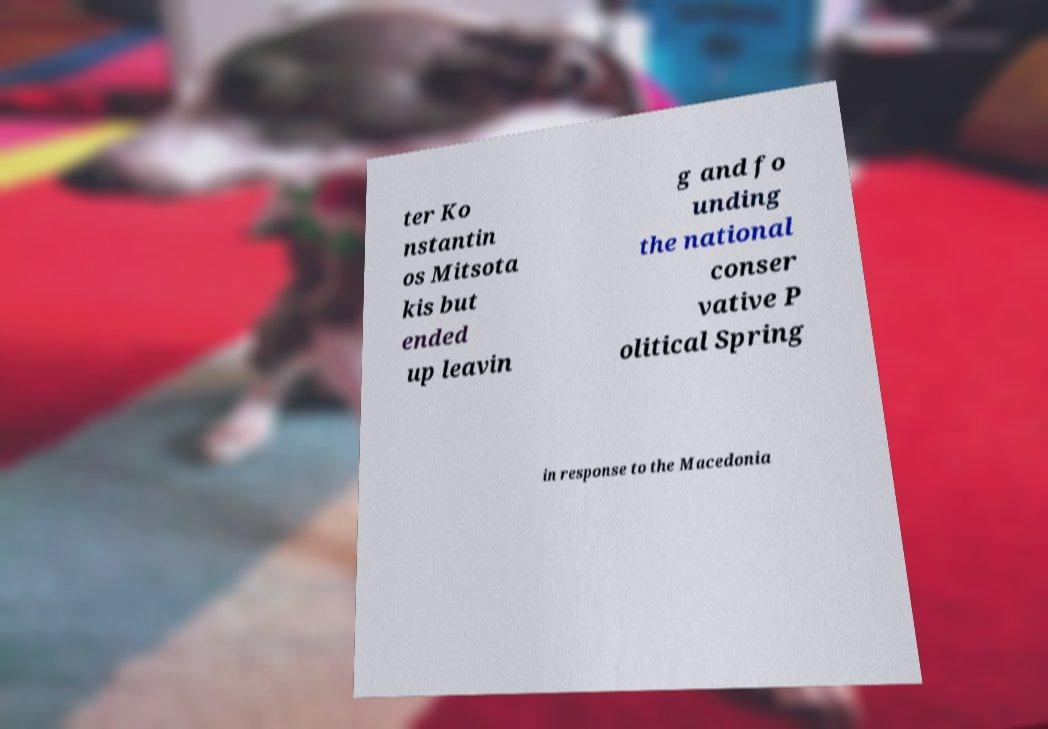There's text embedded in this image that I need extracted. Can you transcribe it verbatim? ter Ko nstantin os Mitsota kis but ended up leavin g and fo unding the national conser vative P olitical Spring in response to the Macedonia 